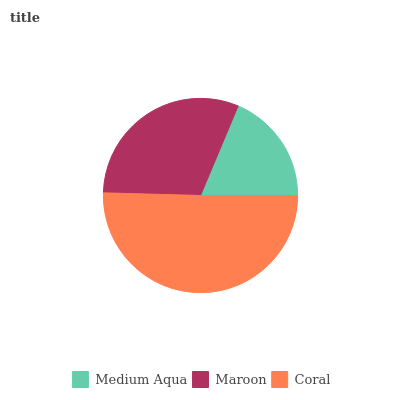Is Medium Aqua the minimum?
Answer yes or no. Yes. Is Coral the maximum?
Answer yes or no. Yes. Is Maroon the minimum?
Answer yes or no. No. Is Maroon the maximum?
Answer yes or no. No. Is Maroon greater than Medium Aqua?
Answer yes or no. Yes. Is Medium Aqua less than Maroon?
Answer yes or no. Yes. Is Medium Aqua greater than Maroon?
Answer yes or no. No. Is Maroon less than Medium Aqua?
Answer yes or no. No. Is Maroon the high median?
Answer yes or no. Yes. Is Maroon the low median?
Answer yes or no. Yes. Is Coral the high median?
Answer yes or no. No. Is Coral the low median?
Answer yes or no. No. 